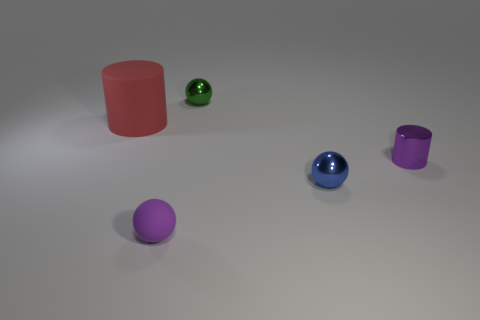Subtract all blue spheres. How many spheres are left? 2 Add 5 tiny green balls. How many objects exist? 10 Subtract all purple balls. How many balls are left? 2 Subtract 1 balls. How many balls are left? 2 Add 3 small shiny things. How many small shiny things are left? 6 Add 3 purple metal cylinders. How many purple metal cylinders exist? 4 Subtract 0 yellow cubes. How many objects are left? 5 Subtract all cylinders. How many objects are left? 3 Subtract all blue cylinders. Subtract all purple blocks. How many cylinders are left? 2 Subtract all tiny purple cylinders. Subtract all tiny purple balls. How many objects are left? 3 